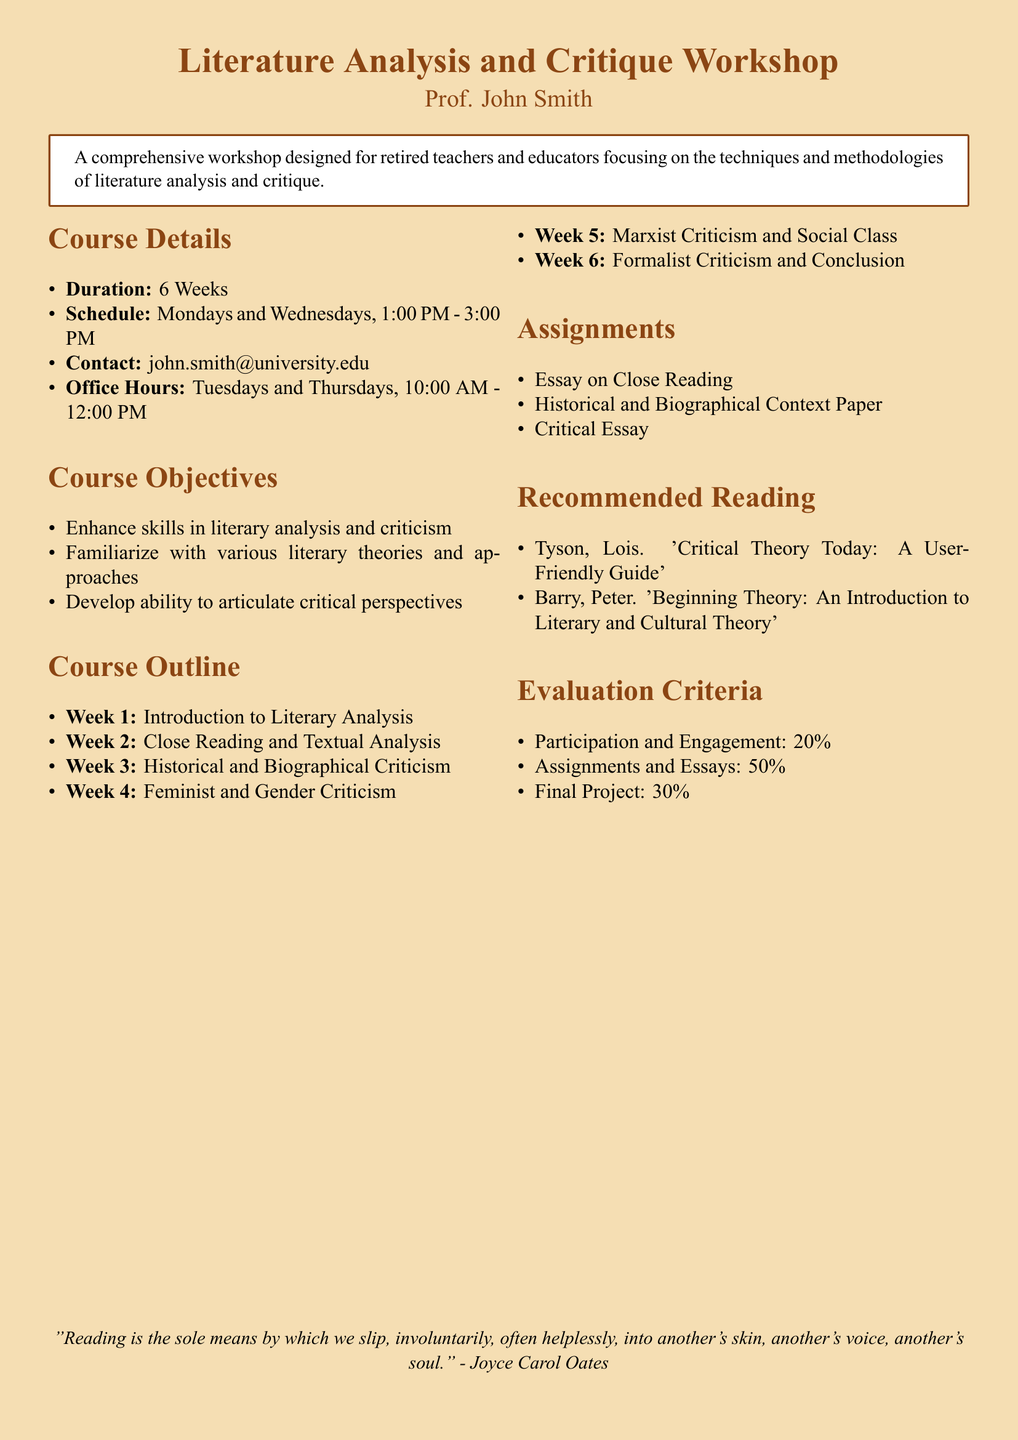What is the course title? The course title is stated at the beginning of the document.
Answer: Literature Analysis and Critique Workshop Who is the instructor? The instructor's name is mentioned in the introduction section of the document.
Answer: Prof. John Smith How long is the workshop? The duration of the workshop is specified in the course details section.
Answer: 6 Weeks On which days does the workshop take place? The schedule of the workshop indicates the specific days.
Answer: Mondays and Wednesdays What percentage of the evaluation criteria is based on assignments and essays? The evaluation criteria are detailed in a specific section of the document.
Answer: 50% Which critical theory text is included in the recommended reading? The recommended reading section lists specific texts related to critical theory.
Answer: Critical Theory Today: A User-Friendly Guide What is the final project percentage in the evaluation criteria? The final project contribution to the total evaluation is outlined in the evaluation criteria section.
Answer: 30% What is the focus of Week 4 in the course outline? The course outline indicates the focus for each week of the workshop.
Answer: Feminist and Gender Criticism Which office hours are designated for the instructor? The specific office hours are stated in the course details section.
Answer: Tuesdays and Thursdays, 10:00 AM - 12:00 PM 